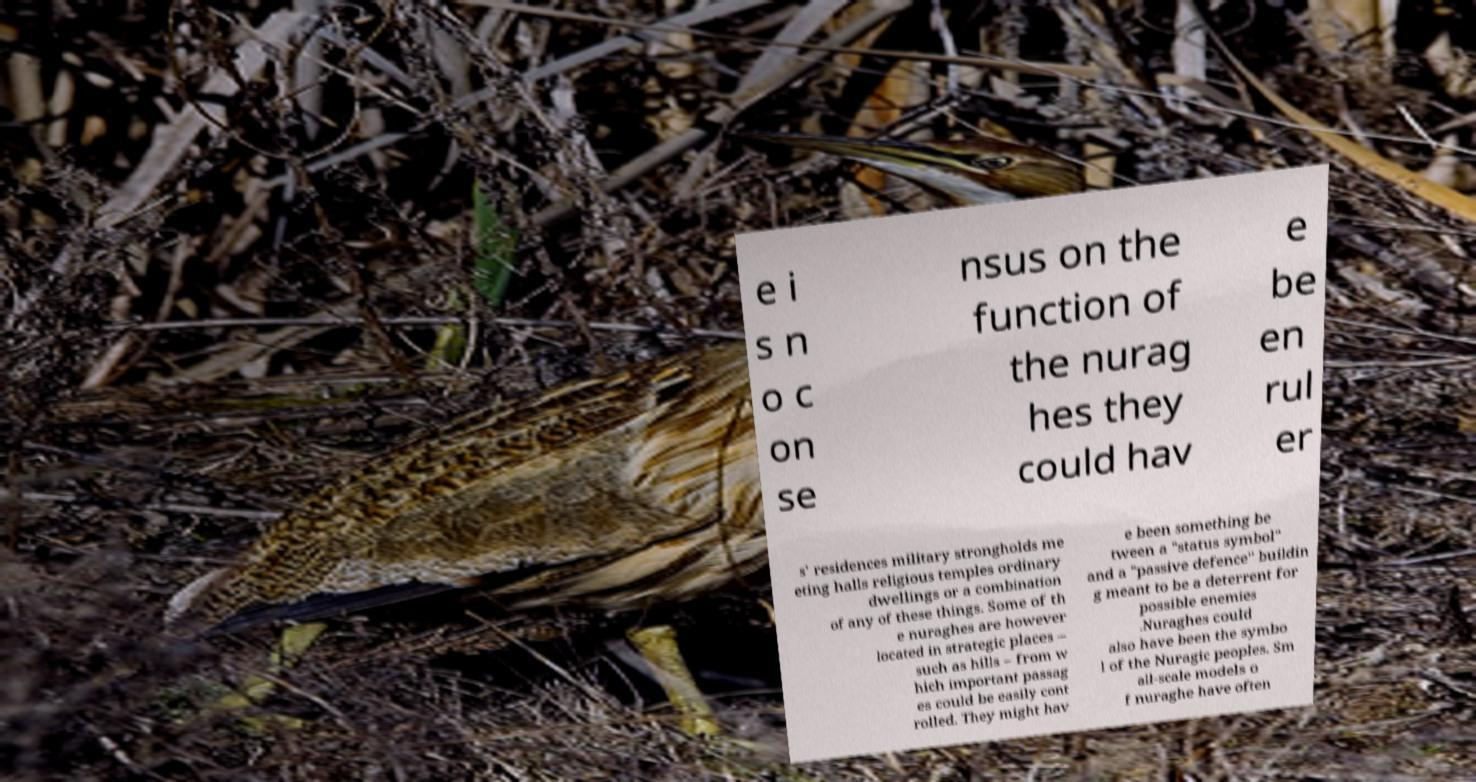There's text embedded in this image that I need extracted. Can you transcribe it verbatim? e i s n o c on se nsus on the function of the nurag hes they could hav e be en rul er s' residences military strongholds me eting halls religious temples ordinary dwellings or a combination of any of these things. Some of th e nuraghes are however located in strategic places – such as hills – from w hich important passag es could be easily cont rolled. They might hav e been something be tween a "status symbol" and a "passive defence" buildin g meant to be a deterrent for possible enemies .Nuraghes could also have been the symbo l of the Nuragic peoples. Sm all-scale models o f nuraghe have often 